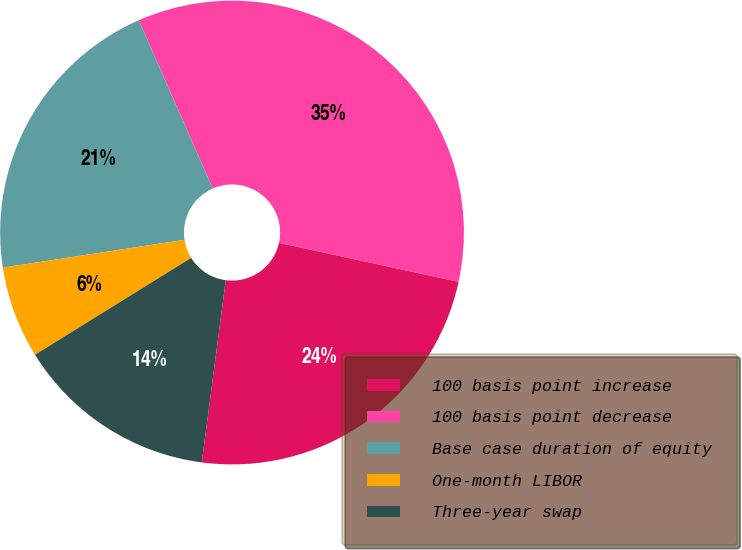Convert chart to OTSL. <chart><loc_0><loc_0><loc_500><loc_500><pie_chart><fcel>100 basis point increase<fcel>100 basis point decrease<fcel>Base case duration of equity<fcel>One-month LIBOR<fcel>Three-year swap<nl><fcel>23.67%<fcel>35.0%<fcel>20.83%<fcel>6.42%<fcel>14.08%<nl></chart> 